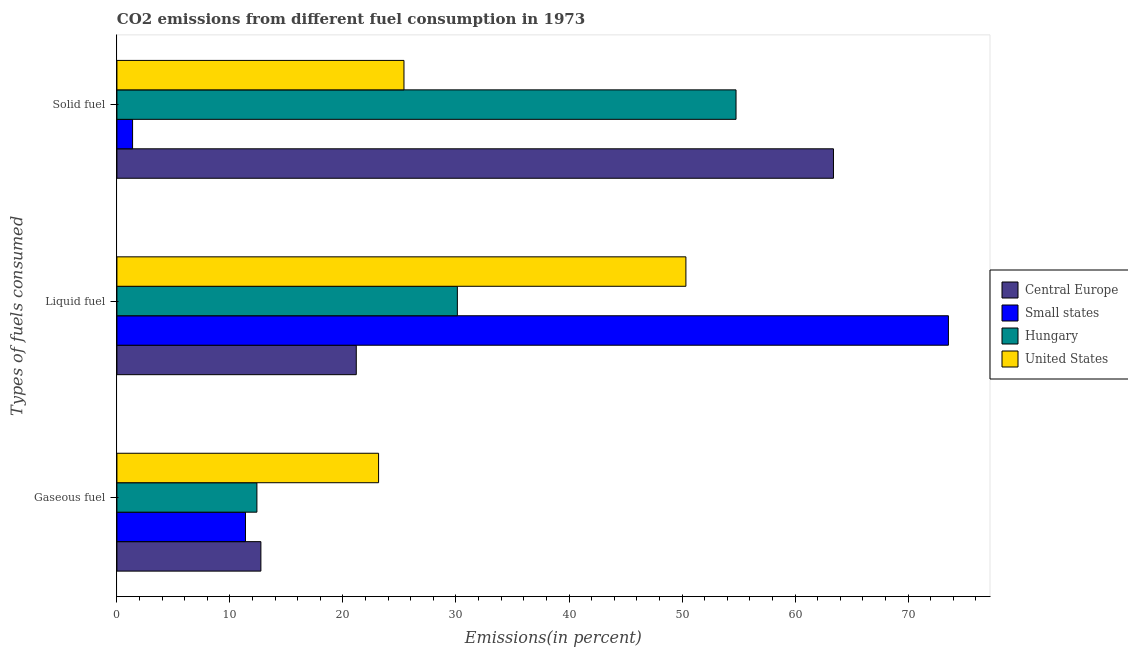How many different coloured bars are there?
Your response must be concise. 4. How many groups of bars are there?
Keep it short and to the point. 3. Are the number of bars per tick equal to the number of legend labels?
Offer a very short reply. Yes. How many bars are there on the 3rd tick from the top?
Make the answer very short. 4. What is the label of the 3rd group of bars from the top?
Ensure brevity in your answer.  Gaseous fuel. What is the percentage of solid fuel emission in Hungary?
Ensure brevity in your answer.  54.78. Across all countries, what is the maximum percentage of gaseous fuel emission?
Your answer should be very brief. 23.15. Across all countries, what is the minimum percentage of liquid fuel emission?
Offer a terse response. 21.18. In which country was the percentage of gaseous fuel emission minimum?
Your answer should be compact. Small states. What is the total percentage of solid fuel emission in the graph?
Your answer should be very brief. 144.96. What is the difference between the percentage of gaseous fuel emission in Central Europe and that in United States?
Provide a succinct answer. -10.41. What is the difference between the percentage of solid fuel emission in Hungary and the percentage of gaseous fuel emission in Central Europe?
Offer a terse response. 42.04. What is the average percentage of gaseous fuel emission per country?
Provide a short and direct response. 14.91. What is the difference between the percentage of gaseous fuel emission and percentage of liquid fuel emission in Small states?
Offer a very short reply. -62.2. In how many countries, is the percentage of liquid fuel emission greater than 62 %?
Ensure brevity in your answer.  1. What is the ratio of the percentage of liquid fuel emission in Small states to that in Hungary?
Ensure brevity in your answer.  2.44. What is the difference between the highest and the second highest percentage of liquid fuel emission?
Your response must be concise. 23.23. What is the difference between the highest and the lowest percentage of liquid fuel emission?
Your response must be concise. 52.39. In how many countries, is the percentage of liquid fuel emission greater than the average percentage of liquid fuel emission taken over all countries?
Provide a short and direct response. 2. Is the sum of the percentage of liquid fuel emission in Small states and Hungary greater than the maximum percentage of gaseous fuel emission across all countries?
Your answer should be compact. Yes. What does the 2nd bar from the top in Gaseous fuel represents?
Your answer should be compact. Hungary. What does the 1st bar from the bottom in Gaseous fuel represents?
Keep it short and to the point. Central Europe. Is it the case that in every country, the sum of the percentage of gaseous fuel emission and percentage of liquid fuel emission is greater than the percentage of solid fuel emission?
Your answer should be very brief. No. How many bars are there?
Keep it short and to the point. 12. Are all the bars in the graph horizontal?
Give a very brief answer. Yes. How many countries are there in the graph?
Give a very brief answer. 4. Are the values on the major ticks of X-axis written in scientific E-notation?
Keep it short and to the point. No. Does the graph contain any zero values?
Your answer should be compact. No. Where does the legend appear in the graph?
Provide a short and direct response. Center right. How are the legend labels stacked?
Your answer should be very brief. Vertical. What is the title of the graph?
Give a very brief answer. CO2 emissions from different fuel consumption in 1973. What is the label or title of the X-axis?
Your answer should be compact. Emissions(in percent). What is the label or title of the Y-axis?
Make the answer very short. Types of fuels consumed. What is the Emissions(in percent) in Central Europe in Gaseous fuel?
Offer a very short reply. 12.74. What is the Emissions(in percent) in Small states in Gaseous fuel?
Keep it short and to the point. 11.37. What is the Emissions(in percent) of Hungary in Gaseous fuel?
Ensure brevity in your answer.  12.39. What is the Emissions(in percent) in United States in Gaseous fuel?
Ensure brevity in your answer.  23.15. What is the Emissions(in percent) in Central Europe in Liquid fuel?
Ensure brevity in your answer.  21.18. What is the Emissions(in percent) in Small states in Liquid fuel?
Ensure brevity in your answer.  73.57. What is the Emissions(in percent) of Hungary in Liquid fuel?
Keep it short and to the point. 30.12. What is the Emissions(in percent) in United States in Liquid fuel?
Ensure brevity in your answer.  50.34. What is the Emissions(in percent) in Central Europe in Solid fuel?
Make the answer very short. 63.4. What is the Emissions(in percent) in Small states in Solid fuel?
Make the answer very short. 1.39. What is the Emissions(in percent) in Hungary in Solid fuel?
Ensure brevity in your answer.  54.78. What is the Emissions(in percent) in United States in Solid fuel?
Give a very brief answer. 25.4. Across all Types of fuels consumed, what is the maximum Emissions(in percent) of Central Europe?
Give a very brief answer. 63.4. Across all Types of fuels consumed, what is the maximum Emissions(in percent) in Small states?
Ensure brevity in your answer.  73.57. Across all Types of fuels consumed, what is the maximum Emissions(in percent) of Hungary?
Offer a very short reply. 54.78. Across all Types of fuels consumed, what is the maximum Emissions(in percent) in United States?
Give a very brief answer. 50.34. Across all Types of fuels consumed, what is the minimum Emissions(in percent) in Central Europe?
Your answer should be compact. 12.74. Across all Types of fuels consumed, what is the minimum Emissions(in percent) in Small states?
Make the answer very short. 1.39. Across all Types of fuels consumed, what is the minimum Emissions(in percent) in Hungary?
Your answer should be compact. 12.39. Across all Types of fuels consumed, what is the minimum Emissions(in percent) in United States?
Give a very brief answer. 23.15. What is the total Emissions(in percent) of Central Europe in the graph?
Ensure brevity in your answer.  97.31. What is the total Emissions(in percent) in Small states in the graph?
Ensure brevity in your answer.  86.33. What is the total Emissions(in percent) in Hungary in the graph?
Offer a very short reply. 97.28. What is the total Emissions(in percent) in United States in the graph?
Your answer should be very brief. 98.89. What is the difference between the Emissions(in percent) of Central Europe in Gaseous fuel and that in Liquid fuel?
Make the answer very short. -8.44. What is the difference between the Emissions(in percent) of Small states in Gaseous fuel and that in Liquid fuel?
Make the answer very short. -62.2. What is the difference between the Emissions(in percent) in Hungary in Gaseous fuel and that in Liquid fuel?
Offer a terse response. -17.74. What is the difference between the Emissions(in percent) in United States in Gaseous fuel and that in Liquid fuel?
Your answer should be very brief. -27.19. What is the difference between the Emissions(in percent) in Central Europe in Gaseous fuel and that in Solid fuel?
Provide a short and direct response. -50.66. What is the difference between the Emissions(in percent) of Small states in Gaseous fuel and that in Solid fuel?
Offer a very short reply. 9.99. What is the difference between the Emissions(in percent) in Hungary in Gaseous fuel and that in Solid fuel?
Give a very brief answer. -42.39. What is the difference between the Emissions(in percent) of United States in Gaseous fuel and that in Solid fuel?
Your response must be concise. -2.25. What is the difference between the Emissions(in percent) in Central Europe in Liquid fuel and that in Solid fuel?
Your response must be concise. -42.22. What is the difference between the Emissions(in percent) of Small states in Liquid fuel and that in Solid fuel?
Keep it short and to the point. 72.18. What is the difference between the Emissions(in percent) in Hungary in Liquid fuel and that in Solid fuel?
Keep it short and to the point. -24.66. What is the difference between the Emissions(in percent) in United States in Liquid fuel and that in Solid fuel?
Make the answer very short. 24.94. What is the difference between the Emissions(in percent) of Central Europe in Gaseous fuel and the Emissions(in percent) of Small states in Liquid fuel?
Offer a terse response. -60.83. What is the difference between the Emissions(in percent) in Central Europe in Gaseous fuel and the Emissions(in percent) in Hungary in Liquid fuel?
Offer a terse response. -17.38. What is the difference between the Emissions(in percent) in Central Europe in Gaseous fuel and the Emissions(in percent) in United States in Liquid fuel?
Your answer should be very brief. -37.6. What is the difference between the Emissions(in percent) in Small states in Gaseous fuel and the Emissions(in percent) in Hungary in Liquid fuel?
Your answer should be very brief. -18.75. What is the difference between the Emissions(in percent) of Small states in Gaseous fuel and the Emissions(in percent) of United States in Liquid fuel?
Your answer should be compact. -38.97. What is the difference between the Emissions(in percent) of Hungary in Gaseous fuel and the Emissions(in percent) of United States in Liquid fuel?
Your answer should be compact. -37.96. What is the difference between the Emissions(in percent) of Central Europe in Gaseous fuel and the Emissions(in percent) of Small states in Solid fuel?
Provide a short and direct response. 11.35. What is the difference between the Emissions(in percent) in Central Europe in Gaseous fuel and the Emissions(in percent) in Hungary in Solid fuel?
Provide a short and direct response. -42.04. What is the difference between the Emissions(in percent) in Central Europe in Gaseous fuel and the Emissions(in percent) in United States in Solid fuel?
Keep it short and to the point. -12.66. What is the difference between the Emissions(in percent) in Small states in Gaseous fuel and the Emissions(in percent) in Hungary in Solid fuel?
Keep it short and to the point. -43.4. What is the difference between the Emissions(in percent) in Small states in Gaseous fuel and the Emissions(in percent) in United States in Solid fuel?
Offer a very short reply. -14.02. What is the difference between the Emissions(in percent) in Hungary in Gaseous fuel and the Emissions(in percent) in United States in Solid fuel?
Offer a terse response. -13.01. What is the difference between the Emissions(in percent) in Central Europe in Liquid fuel and the Emissions(in percent) in Small states in Solid fuel?
Your answer should be very brief. 19.79. What is the difference between the Emissions(in percent) in Central Europe in Liquid fuel and the Emissions(in percent) in Hungary in Solid fuel?
Keep it short and to the point. -33.6. What is the difference between the Emissions(in percent) of Central Europe in Liquid fuel and the Emissions(in percent) of United States in Solid fuel?
Your answer should be compact. -4.22. What is the difference between the Emissions(in percent) of Small states in Liquid fuel and the Emissions(in percent) of Hungary in Solid fuel?
Make the answer very short. 18.79. What is the difference between the Emissions(in percent) in Small states in Liquid fuel and the Emissions(in percent) in United States in Solid fuel?
Make the answer very short. 48.17. What is the difference between the Emissions(in percent) of Hungary in Liquid fuel and the Emissions(in percent) of United States in Solid fuel?
Make the answer very short. 4.72. What is the average Emissions(in percent) of Central Europe per Types of fuels consumed?
Keep it short and to the point. 32.44. What is the average Emissions(in percent) of Small states per Types of fuels consumed?
Offer a very short reply. 28.78. What is the average Emissions(in percent) in Hungary per Types of fuels consumed?
Provide a succinct answer. 32.43. What is the average Emissions(in percent) in United States per Types of fuels consumed?
Your response must be concise. 32.96. What is the difference between the Emissions(in percent) in Central Europe and Emissions(in percent) in Small states in Gaseous fuel?
Your answer should be very brief. 1.36. What is the difference between the Emissions(in percent) of Central Europe and Emissions(in percent) of Hungary in Gaseous fuel?
Your answer should be compact. 0.35. What is the difference between the Emissions(in percent) of Central Europe and Emissions(in percent) of United States in Gaseous fuel?
Your response must be concise. -10.41. What is the difference between the Emissions(in percent) in Small states and Emissions(in percent) in Hungary in Gaseous fuel?
Your answer should be very brief. -1.01. What is the difference between the Emissions(in percent) in Small states and Emissions(in percent) in United States in Gaseous fuel?
Offer a terse response. -11.78. What is the difference between the Emissions(in percent) in Hungary and Emissions(in percent) in United States in Gaseous fuel?
Ensure brevity in your answer.  -10.77. What is the difference between the Emissions(in percent) in Central Europe and Emissions(in percent) in Small states in Liquid fuel?
Offer a terse response. -52.39. What is the difference between the Emissions(in percent) of Central Europe and Emissions(in percent) of Hungary in Liquid fuel?
Offer a terse response. -8.94. What is the difference between the Emissions(in percent) in Central Europe and Emissions(in percent) in United States in Liquid fuel?
Offer a very short reply. -29.16. What is the difference between the Emissions(in percent) of Small states and Emissions(in percent) of Hungary in Liquid fuel?
Your response must be concise. 43.45. What is the difference between the Emissions(in percent) of Small states and Emissions(in percent) of United States in Liquid fuel?
Offer a very short reply. 23.23. What is the difference between the Emissions(in percent) in Hungary and Emissions(in percent) in United States in Liquid fuel?
Offer a terse response. -20.22. What is the difference between the Emissions(in percent) in Central Europe and Emissions(in percent) in Small states in Solid fuel?
Provide a succinct answer. 62.01. What is the difference between the Emissions(in percent) in Central Europe and Emissions(in percent) in Hungary in Solid fuel?
Offer a very short reply. 8.62. What is the difference between the Emissions(in percent) of Central Europe and Emissions(in percent) of United States in Solid fuel?
Give a very brief answer. 38. What is the difference between the Emissions(in percent) in Small states and Emissions(in percent) in Hungary in Solid fuel?
Offer a terse response. -53.39. What is the difference between the Emissions(in percent) of Small states and Emissions(in percent) of United States in Solid fuel?
Provide a succinct answer. -24.01. What is the difference between the Emissions(in percent) in Hungary and Emissions(in percent) in United States in Solid fuel?
Keep it short and to the point. 29.38. What is the ratio of the Emissions(in percent) in Central Europe in Gaseous fuel to that in Liquid fuel?
Give a very brief answer. 0.6. What is the ratio of the Emissions(in percent) of Small states in Gaseous fuel to that in Liquid fuel?
Make the answer very short. 0.15. What is the ratio of the Emissions(in percent) in Hungary in Gaseous fuel to that in Liquid fuel?
Offer a very short reply. 0.41. What is the ratio of the Emissions(in percent) of United States in Gaseous fuel to that in Liquid fuel?
Give a very brief answer. 0.46. What is the ratio of the Emissions(in percent) of Central Europe in Gaseous fuel to that in Solid fuel?
Your answer should be very brief. 0.2. What is the ratio of the Emissions(in percent) in Small states in Gaseous fuel to that in Solid fuel?
Your answer should be very brief. 8.21. What is the ratio of the Emissions(in percent) of Hungary in Gaseous fuel to that in Solid fuel?
Keep it short and to the point. 0.23. What is the ratio of the Emissions(in percent) of United States in Gaseous fuel to that in Solid fuel?
Your response must be concise. 0.91. What is the ratio of the Emissions(in percent) of Central Europe in Liquid fuel to that in Solid fuel?
Provide a short and direct response. 0.33. What is the ratio of the Emissions(in percent) in Small states in Liquid fuel to that in Solid fuel?
Provide a succinct answer. 53.12. What is the ratio of the Emissions(in percent) in Hungary in Liquid fuel to that in Solid fuel?
Offer a very short reply. 0.55. What is the ratio of the Emissions(in percent) in United States in Liquid fuel to that in Solid fuel?
Provide a succinct answer. 1.98. What is the difference between the highest and the second highest Emissions(in percent) of Central Europe?
Offer a terse response. 42.22. What is the difference between the highest and the second highest Emissions(in percent) of Small states?
Provide a succinct answer. 62.2. What is the difference between the highest and the second highest Emissions(in percent) in Hungary?
Your response must be concise. 24.66. What is the difference between the highest and the second highest Emissions(in percent) of United States?
Give a very brief answer. 24.94. What is the difference between the highest and the lowest Emissions(in percent) in Central Europe?
Your response must be concise. 50.66. What is the difference between the highest and the lowest Emissions(in percent) in Small states?
Provide a succinct answer. 72.18. What is the difference between the highest and the lowest Emissions(in percent) in Hungary?
Your answer should be compact. 42.39. What is the difference between the highest and the lowest Emissions(in percent) of United States?
Keep it short and to the point. 27.19. 